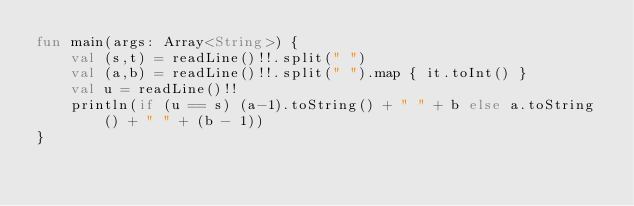Convert code to text. <code><loc_0><loc_0><loc_500><loc_500><_Kotlin_>fun main(args: Array<String>) {
    val (s,t) = readLine()!!.split(" ")
    val (a,b) = readLine()!!.split(" ").map { it.toInt() }
    val u = readLine()!!
    println(if (u == s) (a-1).toString() + " " + b else a.toString() + " " + (b - 1))
}</code> 